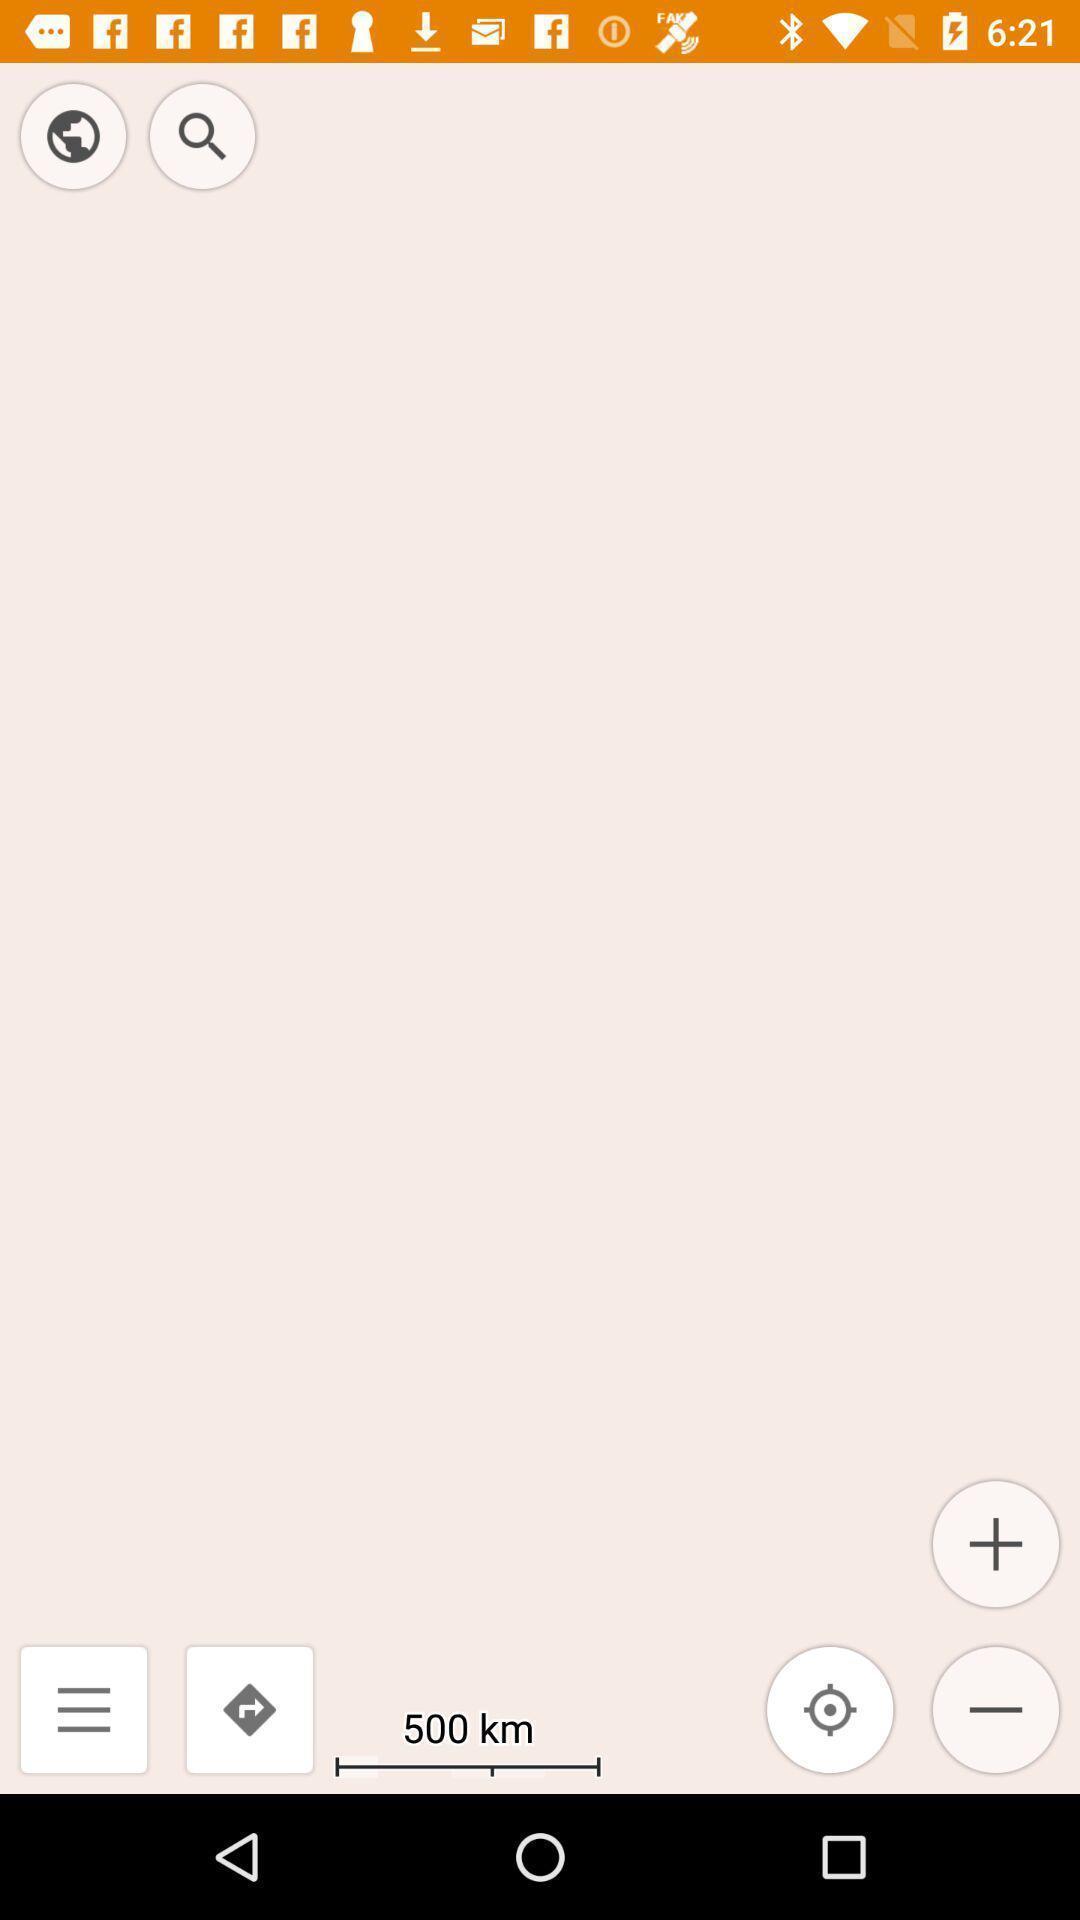Describe the visual elements of this screenshot. Search bar to search for the location. 